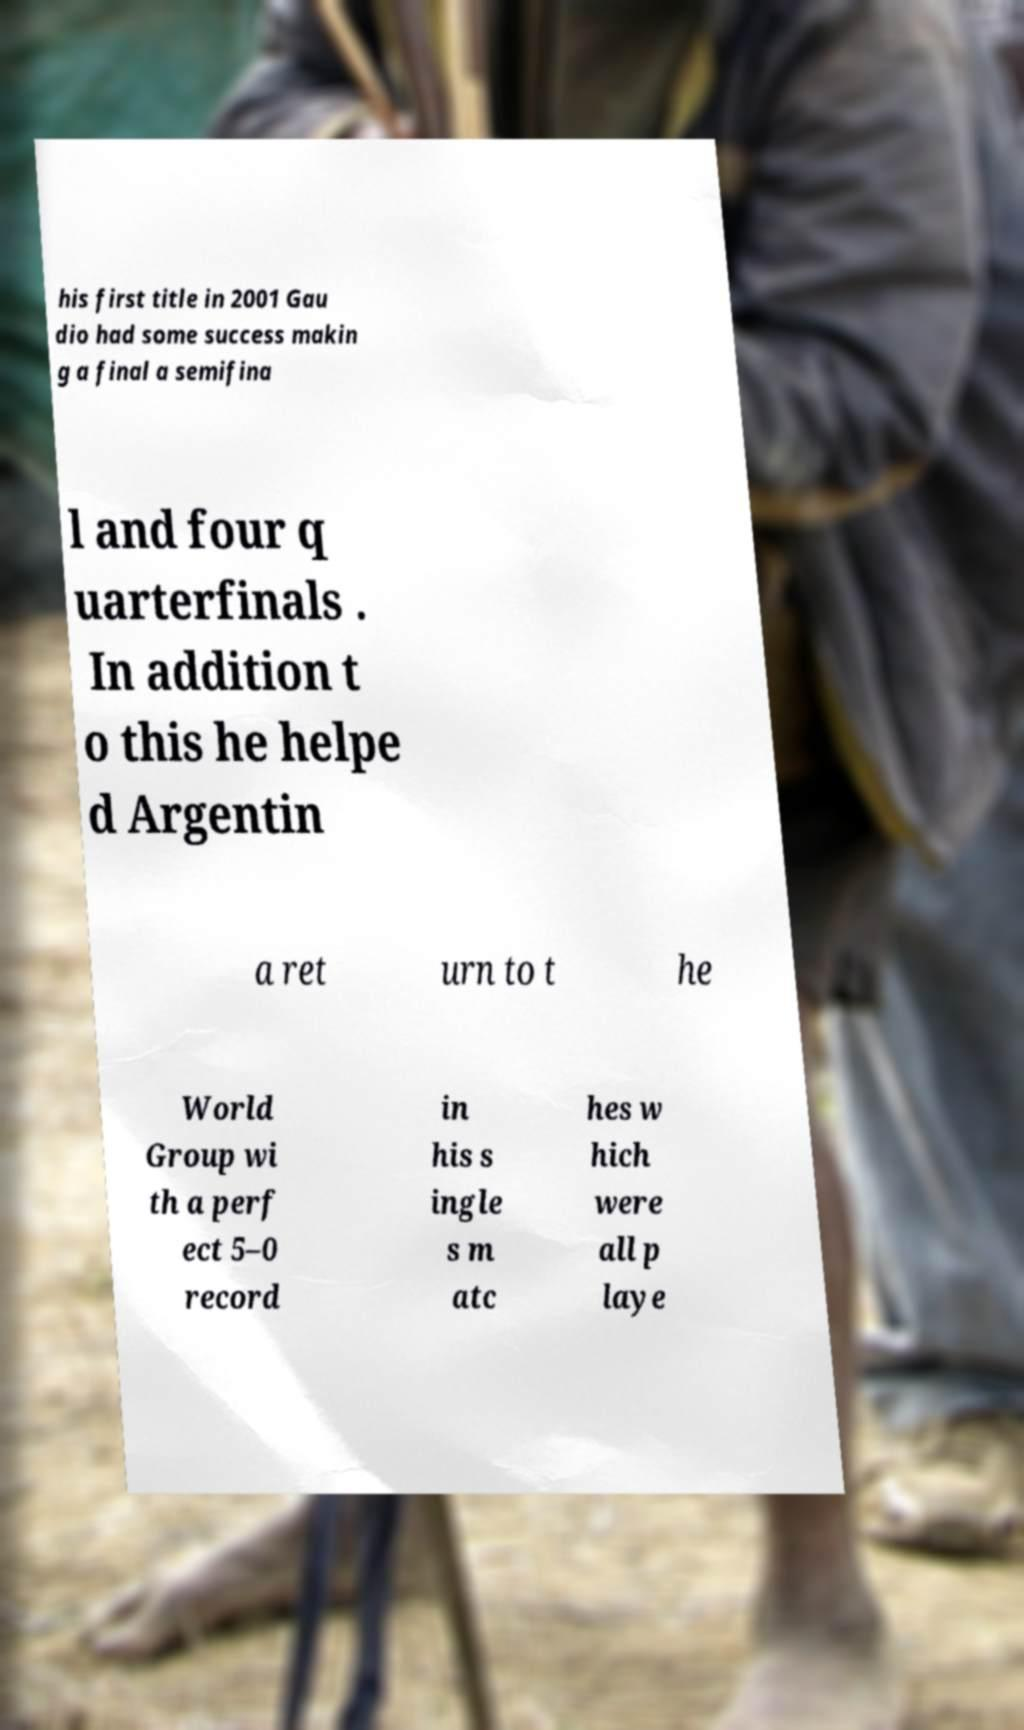I need the written content from this picture converted into text. Can you do that? his first title in 2001 Gau dio had some success makin g a final a semifina l and four q uarterfinals . In addition t o this he helpe d Argentin a ret urn to t he World Group wi th a perf ect 5–0 record in his s ingle s m atc hes w hich were all p laye 